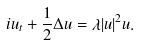<formula> <loc_0><loc_0><loc_500><loc_500>i u _ { t } + \frac { 1 } { 2 } \Delta u = \lambda | u | ^ { 2 } u .</formula> 